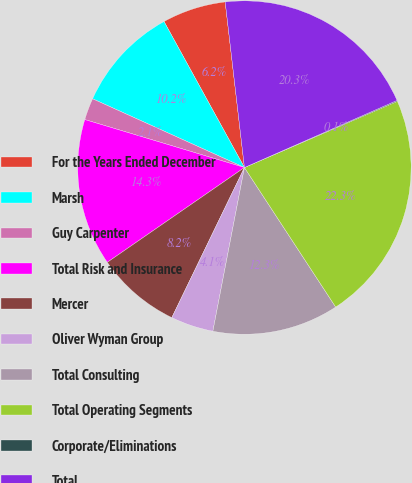<chart> <loc_0><loc_0><loc_500><loc_500><pie_chart><fcel>For the Years Ended December<fcel>Marsh<fcel>Guy Carpenter<fcel>Total Risk and Insurance<fcel>Mercer<fcel>Oliver Wyman Group<fcel>Total Consulting<fcel>Total Operating Segments<fcel>Corporate/Eliminations<fcel>Total<nl><fcel>6.17%<fcel>10.22%<fcel>2.12%<fcel>14.27%<fcel>8.2%<fcel>4.14%<fcel>12.25%<fcel>22.28%<fcel>0.09%<fcel>20.25%<nl></chart> 